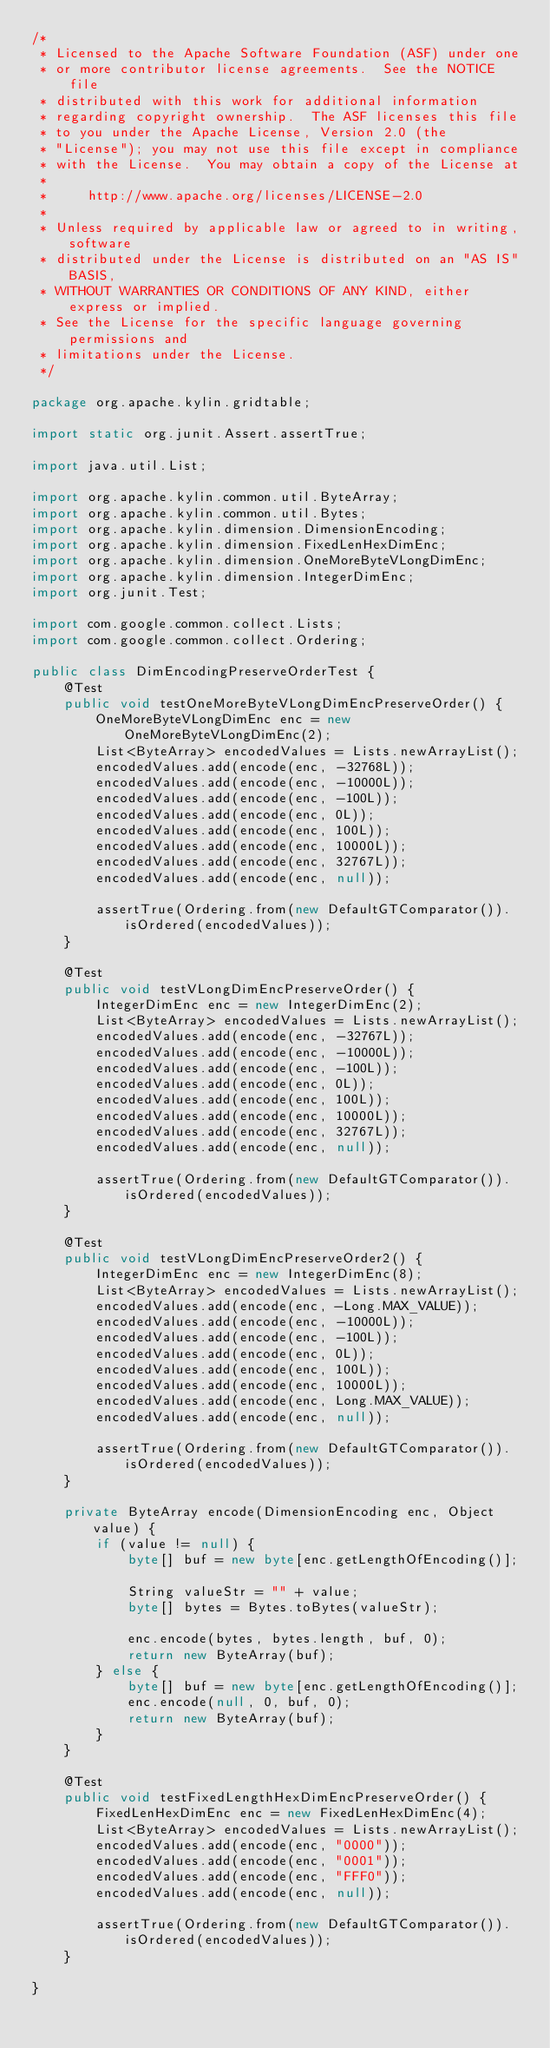Convert code to text. <code><loc_0><loc_0><loc_500><loc_500><_Java_>/*
 * Licensed to the Apache Software Foundation (ASF) under one
 * or more contributor license agreements.  See the NOTICE file
 * distributed with this work for additional information
 * regarding copyright ownership.  The ASF licenses this file
 * to you under the Apache License, Version 2.0 (the
 * "License"); you may not use this file except in compliance
 * with the License.  You may obtain a copy of the License at
 *  
 *     http://www.apache.org/licenses/LICENSE-2.0
 *  
 * Unless required by applicable law or agreed to in writing, software
 * distributed under the License is distributed on an "AS IS" BASIS,
 * WITHOUT WARRANTIES OR CONDITIONS OF ANY KIND, either express or implied.
 * See the License for the specific language governing permissions and
 * limitations under the License.
 */

package org.apache.kylin.gridtable;

import static org.junit.Assert.assertTrue;

import java.util.List;

import org.apache.kylin.common.util.ByteArray;
import org.apache.kylin.common.util.Bytes;
import org.apache.kylin.dimension.DimensionEncoding;
import org.apache.kylin.dimension.FixedLenHexDimEnc;
import org.apache.kylin.dimension.OneMoreByteVLongDimEnc;
import org.apache.kylin.dimension.IntegerDimEnc;
import org.junit.Test;

import com.google.common.collect.Lists;
import com.google.common.collect.Ordering;

public class DimEncodingPreserveOrderTest {
    @Test
    public void testOneMoreByteVLongDimEncPreserveOrder() {
        OneMoreByteVLongDimEnc enc = new OneMoreByteVLongDimEnc(2);
        List<ByteArray> encodedValues = Lists.newArrayList();
        encodedValues.add(encode(enc, -32768L));
        encodedValues.add(encode(enc, -10000L));
        encodedValues.add(encode(enc, -100L));
        encodedValues.add(encode(enc, 0L));
        encodedValues.add(encode(enc, 100L));
        encodedValues.add(encode(enc, 10000L));
        encodedValues.add(encode(enc, 32767L));
        encodedValues.add(encode(enc, null));

        assertTrue(Ordering.from(new DefaultGTComparator()).isOrdered(encodedValues));
    }

    @Test
    public void testVLongDimEncPreserveOrder() {
        IntegerDimEnc enc = new IntegerDimEnc(2);
        List<ByteArray> encodedValues = Lists.newArrayList();
        encodedValues.add(encode(enc, -32767L));
        encodedValues.add(encode(enc, -10000L));
        encodedValues.add(encode(enc, -100L));
        encodedValues.add(encode(enc, 0L));
        encodedValues.add(encode(enc, 100L));
        encodedValues.add(encode(enc, 10000L));
        encodedValues.add(encode(enc, 32767L));
        encodedValues.add(encode(enc, null));

        assertTrue(Ordering.from(new DefaultGTComparator()).isOrdered(encodedValues));
    }

    @Test
    public void testVLongDimEncPreserveOrder2() {
        IntegerDimEnc enc = new IntegerDimEnc(8);
        List<ByteArray> encodedValues = Lists.newArrayList();
        encodedValues.add(encode(enc, -Long.MAX_VALUE));
        encodedValues.add(encode(enc, -10000L));
        encodedValues.add(encode(enc, -100L));
        encodedValues.add(encode(enc, 0L));
        encodedValues.add(encode(enc, 100L));
        encodedValues.add(encode(enc, 10000L));
        encodedValues.add(encode(enc, Long.MAX_VALUE));
        encodedValues.add(encode(enc, null));

        assertTrue(Ordering.from(new DefaultGTComparator()).isOrdered(encodedValues));
    }

    private ByteArray encode(DimensionEncoding enc, Object value) {
        if (value != null) {
            byte[] buf = new byte[enc.getLengthOfEncoding()];

            String valueStr = "" + value;
            byte[] bytes = Bytes.toBytes(valueStr);

            enc.encode(bytes, bytes.length, buf, 0);
            return new ByteArray(buf);
        } else {
            byte[] buf = new byte[enc.getLengthOfEncoding()];
            enc.encode(null, 0, buf, 0);
            return new ByteArray(buf);
        }
    }

    @Test
    public void testFixedLengthHexDimEncPreserveOrder() {
        FixedLenHexDimEnc enc = new FixedLenHexDimEnc(4);
        List<ByteArray> encodedValues = Lists.newArrayList();
        encodedValues.add(encode(enc, "0000"));
        encodedValues.add(encode(enc, "0001"));
        encodedValues.add(encode(enc, "FFF0"));
        encodedValues.add(encode(enc, null));

        assertTrue(Ordering.from(new DefaultGTComparator()).isOrdered(encodedValues));
    }

}
</code> 